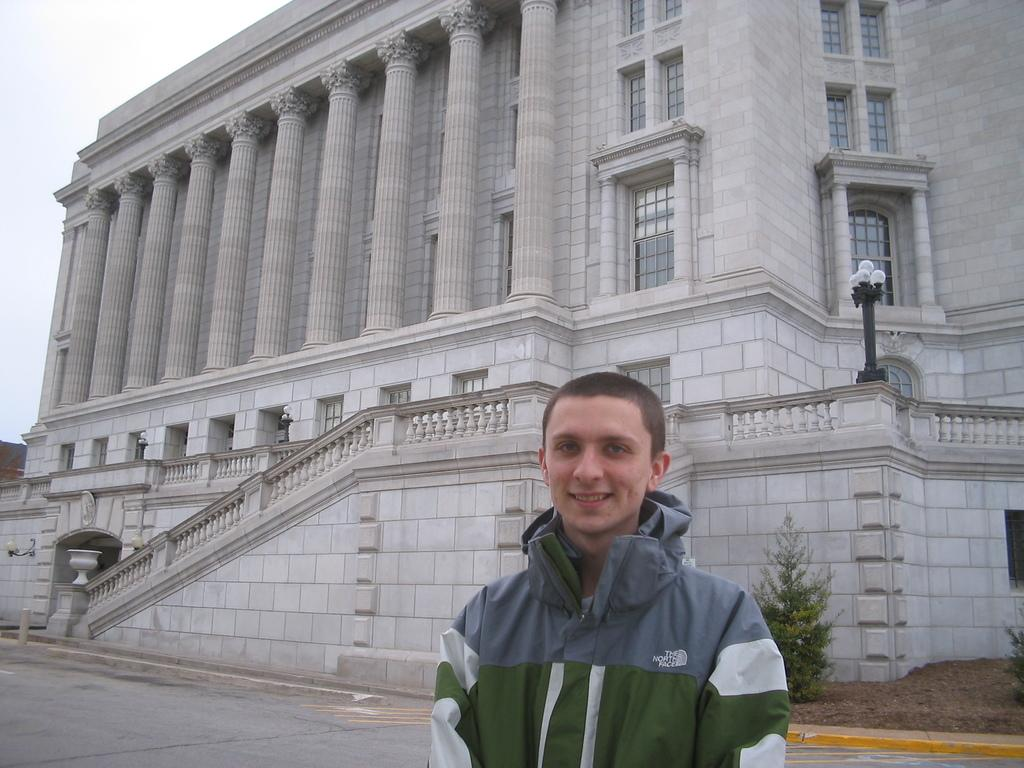<image>
Describe the image concisely. A boy wearing a north face jacket stands in front of a building with large pillars. 